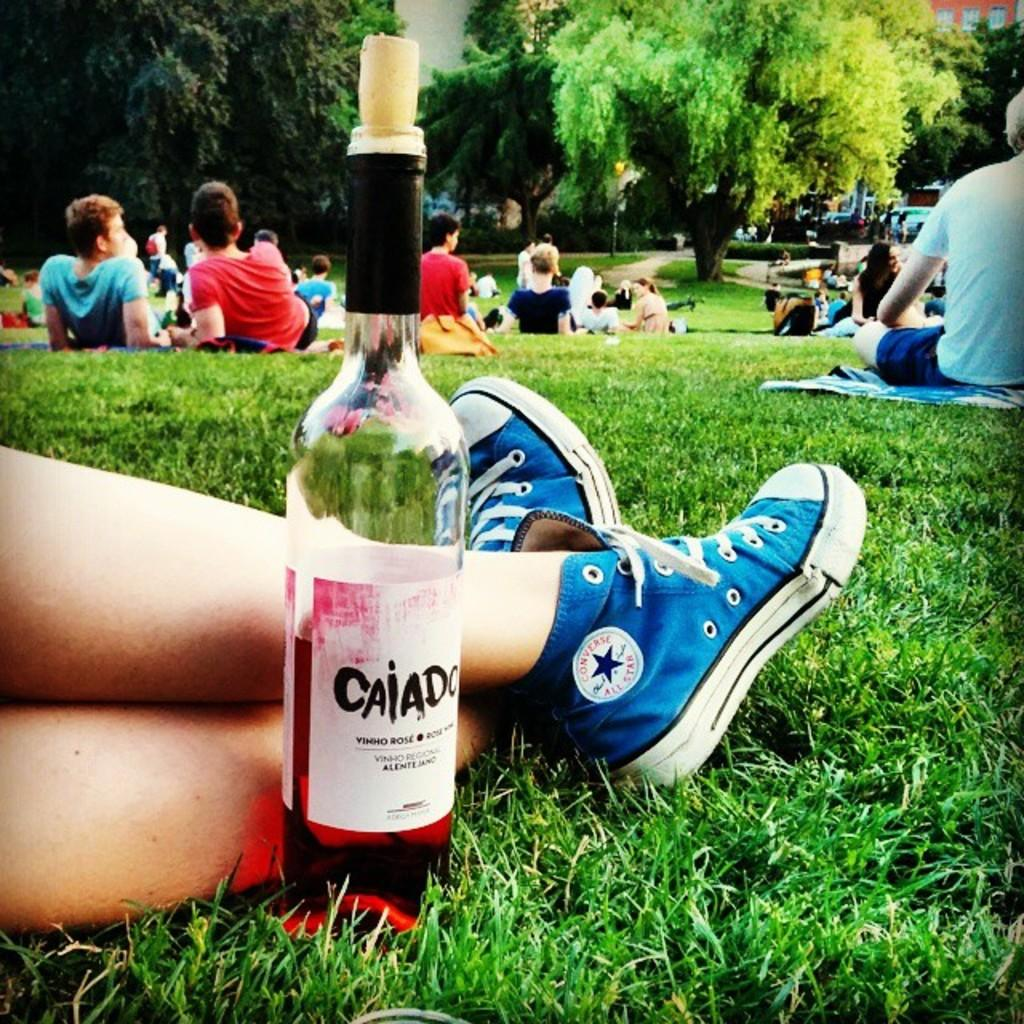What is the main subject of the image? The main subject of the image is a group of people. Where are the people located in the image? The people are resting on grass in the image. Can you describe the person beside a bottle in the image? Yes, there is a person beside a bottle in the image. What can be seen in the background of the image? There is a building with windows in the background of the image. What type of furniture is being used by the people in the image? There is no furniture visible in the image; the people are resting on grass. What sound can be heard coming from the box in the image? There is no box or sound present in the image. 